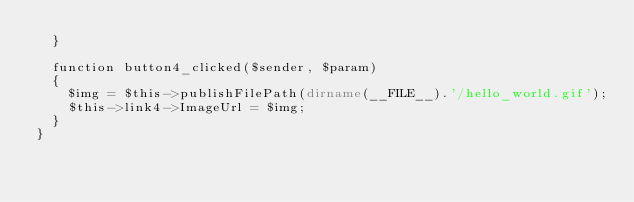Convert code to text. <code><loc_0><loc_0><loc_500><loc_500><_PHP_>	}

	function button4_clicked($sender, $param)
	{
		$img = $this->publishFilePath(dirname(__FILE__).'/hello_world.gif');
		$this->link4->ImageUrl = $img;
	}
}
</code> 